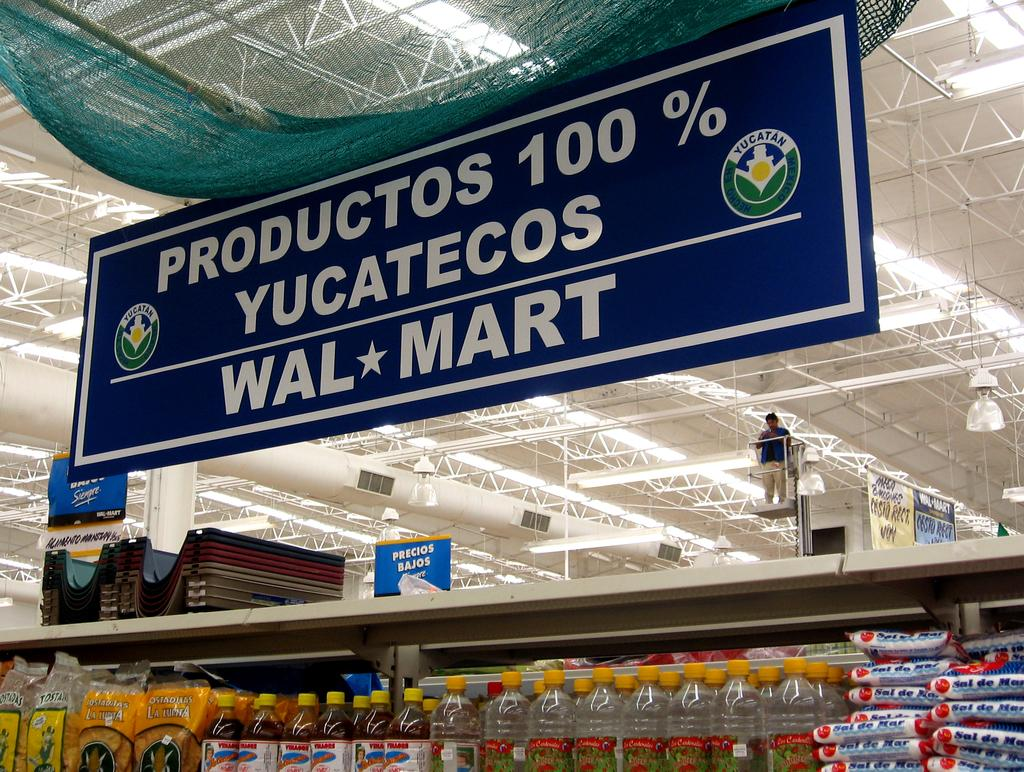Provide a one-sentence caption for the provided image. A sign in a store that reads productos 100%, yucatecos, walmart. 